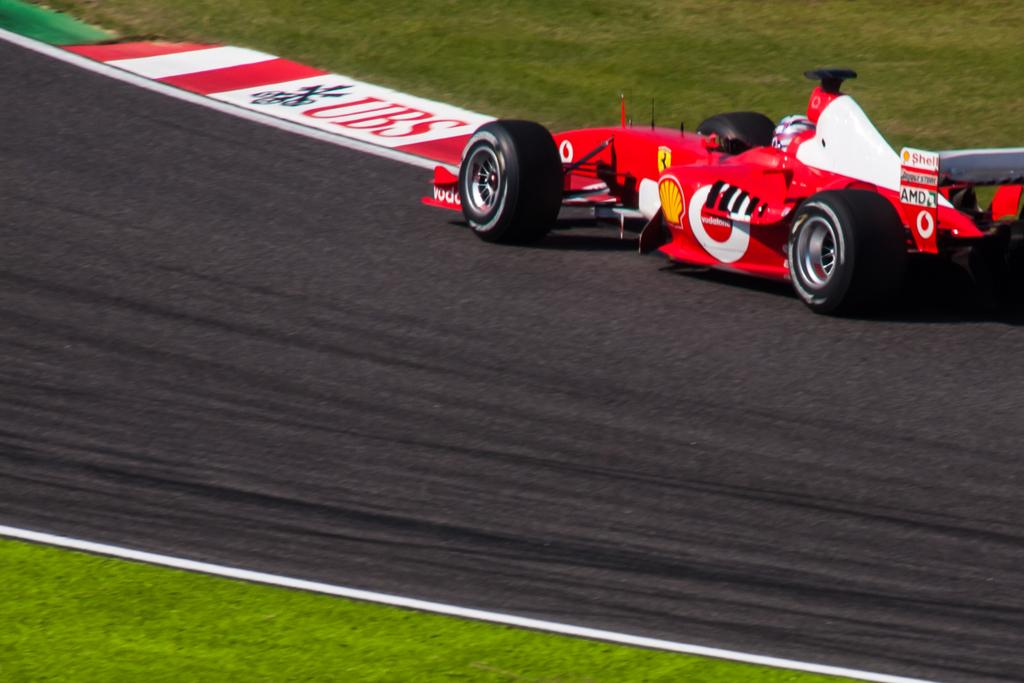What is the main subject on the road in the image? There is a vehicle on the road in the image. What else can be seen in the image besides the vehicle? There is a board in the image. What type of box is being used to wash the vehicle in the image? There is no box or washing activity present in the image; it only features a vehicle on the road and a board. 